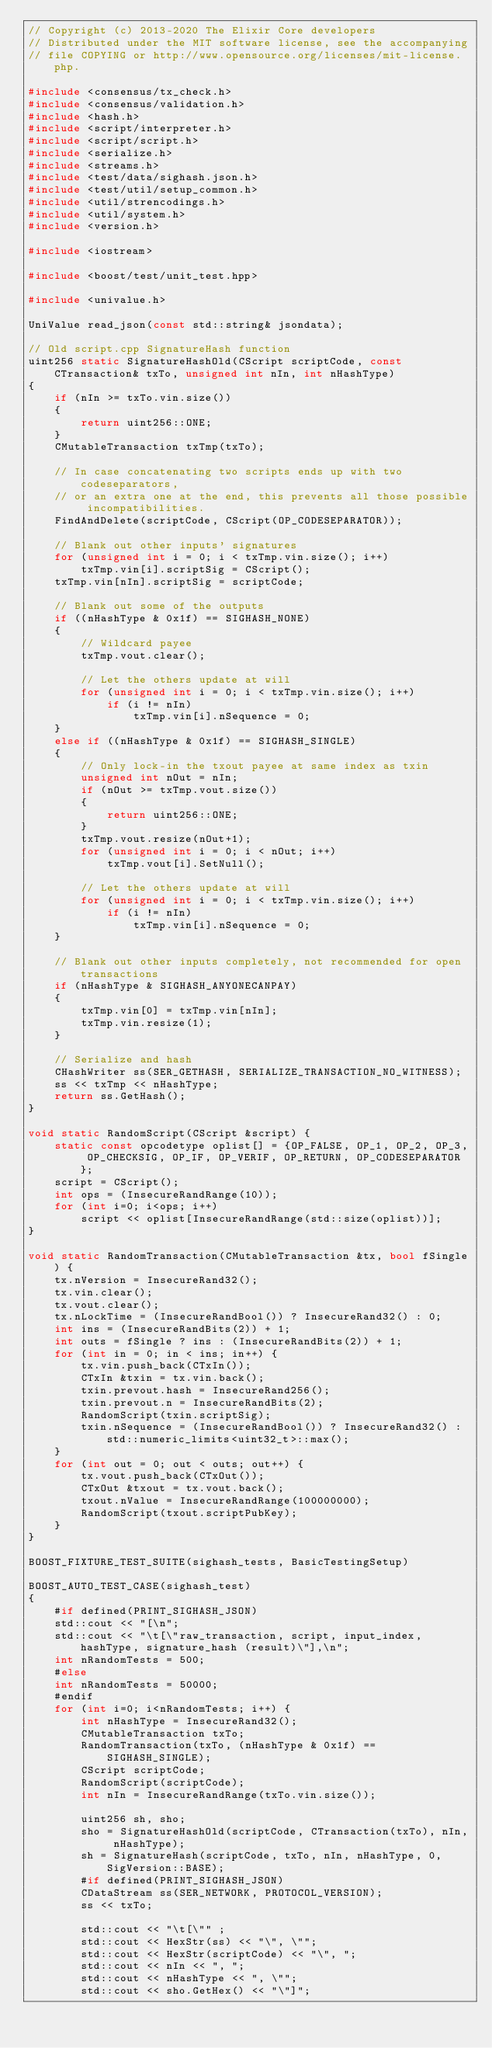Convert code to text. <code><loc_0><loc_0><loc_500><loc_500><_C++_>// Copyright (c) 2013-2020 The Elixir Core developers
// Distributed under the MIT software license, see the accompanying
// file COPYING or http://www.opensource.org/licenses/mit-license.php.

#include <consensus/tx_check.h>
#include <consensus/validation.h>
#include <hash.h>
#include <script/interpreter.h>
#include <script/script.h>
#include <serialize.h>
#include <streams.h>
#include <test/data/sighash.json.h>
#include <test/util/setup_common.h>
#include <util/strencodings.h>
#include <util/system.h>
#include <version.h>

#include <iostream>

#include <boost/test/unit_test.hpp>

#include <univalue.h>

UniValue read_json(const std::string& jsondata);

// Old script.cpp SignatureHash function
uint256 static SignatureHashOld(CScript scriptCode, const CTransaction& txTo, unsigned int nIn, int nHashType)
{
    if (nIn >= txTo.vin.size())
    {
        return uint256::ONE;
    }
    CMutableTransaction txTmp(txTo);

    // In case concatenating two scripts ends up with two codeseparators,
    // or an extra one at the end, this prevents all those possible incompatibilities.
    FindAndDelete(scriptCode, CScript(OP_CODESEPARATOR));

    // Blank out other inputs' signatures
    for (unsigned int i = 0; i < txTmp.vin.size(); i++)
        txTmp.vin[i].scriptSig = CScript();
    txTmp.vin[nIn].scriptSig = scriptCode;

    // Blank out some of the outputs
    if ((nHashType & 0x1f) == SIGHASH_NONE)
    {
        // Wildcard payee
        txTmp.vout.clear();

        // Let the others update at will
        for (unsigned int i = 0; i < txTmp.vin.size(); i++)
            if (i != nIn)
                txTmp.vin[i].nSequence = 0;
    }
    else if ((nHashType & 0x1f) == SIGHASH_SINGLE)
    {
        // Only lock-in the txout payee at same index as txin
        unsigned int nOut = nIn;
        if (nOut >= txTmp.vout.size())
        {
            return uint256::ONE;
        }
        txTmp.vout.resize(nOut+1);
        for (unsigned int i = 0; i < nOut; i++)
            txTmp.vout[i].SetNull();

        // Let the others update at will
        for (unsigned int i = 0; i < txTmp.vin.size(); i++)
            if (i != nIn)
                txTmp.vin[i].nSequence = 0;
    }

    // Blank out other inputs completely, not recommended for open transactions
    if (nHashType & SIGHASH_ANYONECANPAY)
    {
        txTmp.vin[0] = txTmp.vin[nIn];
        txTmp.vin.resize(1);
    }

    // Serialize and hash
    CHashWriter ss(SER_GETHASH, SERIALIZE_TRANSACTION_NO_WITNESS);
    ss << txTmp << nHashType;
    return ss.GetHash();
}

void static RandomScript(CScript &script) {
    static const opcodetype oplist[] = {OP_FALSE, OP_1, OP_2, OP_3, OP_CHECKSIG, OP_IF, OP_VERIF, OP_RETURN, OP_CODESEPARATOR};
    script = CScript();
    int ops = (InsecureRandRange(10));
    for (int i=0; i<ops; i++)
        script << oplist[InsecureRandRange(std::size(oplist))];
}

void static RandomTransaction(CMutableTransaction &tx, bool fSingle) {
    tx.nVersion = InsecureRand32();
    tx.vin.clear();
    tx.vout.clear();
    tx.nLockTime = (InsecureRandBool()) ? InsecureRand32() : 0;
    int ins = (InsecureRandBits(2)) + 1;
    int outs = fSingle ? ins : (InsecureRandBits(2)) + 1;
    for (int in = 0; in < ins; in++) {
        tx.vin.push_back(CTxIn());
        CTxIn &txin = tx.vin.back();
        txin.prevout.hash = InsecureRand256();
        txin.prevout.n = InsecureRandBits(2);
        RandomScript(txin.scriptSig);
        txin.nSequence = (InsecureRandBool()) ? InsecureRand32() : std::numeric_limits<uint32_t>::max();
    }
    for (int out = 0; out < outs; out++) {
        tx.vout.push_back(CTxOut());
        CTxOut &txout = tx.vout.back();
        txout.nValue = InsecureRandRange(100000000);
        RandomScript(txout.scriptPubKey);
    }
}

BOOST_FIXTURE_TEST_SUITE(sighash_tests, BasicTestingSetup)

BOOST_AUTO_TEST_CASE(sighash_test)
{
    #if defined(PRINT_SIGHASH_JSON)
    std::cout << "[\n";
    std::cout << "\t[\"raw_transaction, script, input_index, hashType, signature_hash (result)\"],\n";
    int nRandomTests = 500;
    #else
    int nRandomTests = 50000;
    #endif
    for (int i=0; i<nRandomTests; i++) {
        int nHashType = InsecureRand32();
        CMutableTransaction txTo;
        RandomTransaction(txTo, (nHashType & 0x1f) == SIGHASH_SINGLE);
        CScript scriptCode;
        RandomScript(scriptCode);
        int nIn = InsecureRandRange(txTo.vin.size());

        uint256 sh, sho;
        sho = SignatureHashOld(scriptCode, CTransaction(txTo), nIn, nHashType);
        sh = SignatureHash(scriptCode, txTo, nIn, nHashType, 0, SigVersion::BASE);
        #if defined(PRINT_SIGHASH_JSON)
        CDataStream ss(SER_NETWORK, PROTOCOL_VERSION);
        ss << txTo;

        std::cout << "\t[\"" ;
        std::cout << HexStr(ss) << "\", \"";
        std::cout << HexStr(scriptCode) << "\", ";
        std::cout << nIn << ", ";
        std::cout << nHashType << ", \"";
        std::cout << sho.GetHex() << "\"]";</code> 